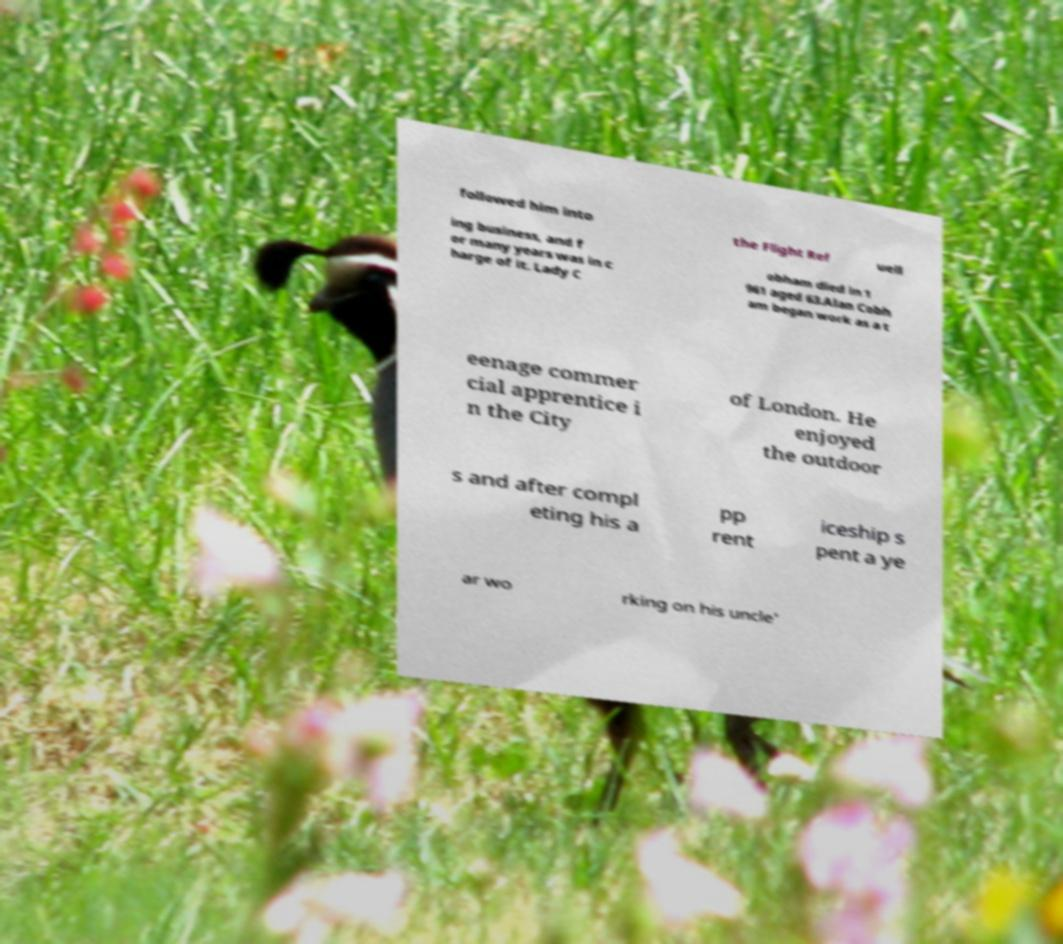I need the written content from this picture converted into text. Can you do that? followed him into the Flight Ref uell ing business, and f or many years was in c harge of it. Lady C obham died in 1 961 aged 63.Alan Cobh am began work as a t eenage commer cial apprentice i n the City of London. He enjoyed the outdoor s and after compl eting his a pp rent iceship s pent a ye ar wo rking on his uncle' 